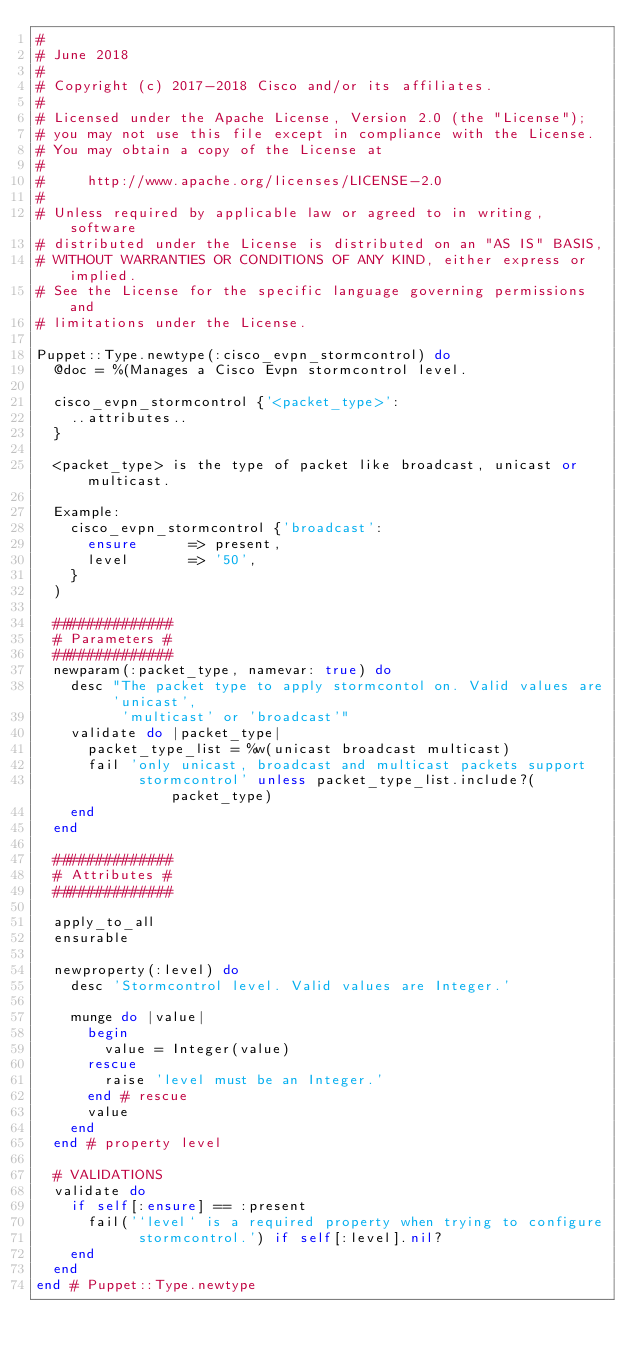Convert code to text. <code><loc_0><loc_0><loc_500><loc_500><_Ruby_>#
# June 2018
#
# Copyright (c) 2017-2018 Cisco and/or its affiliates.
#
# Licensed under the Apache License, Version 2.0 (the "License");
# you may not use this file except in compliance with the License.
# You may obtain a copy of the License at
#
#     http://www.apache.org/licenses/LICENSE-2.0
#
# Unless required by applicable law or agreed to in writing, software
# distributed under the License is distributed on an "AS IS" BASIS,
# WITHOUT WARRANTIES OR CONDITIONS OF ANY KIND, either express or implied.
# See the License for the specific language governing permissions and
# limitations under the License.

Puppet::Type.newtype(:cisco_evpn_stormcontrol) do
  @doc = %(Manages a Cisco Evpn stormcontrol level.

  cisco_evpn_stormcontrol {'<packet_type>':
    ..attributes..
  }

  <packet_type> is the type of packet like broadcast, unicast or multicast.

  Example:
    cisco_evpn_stormcontrol {'broadcast':
      ensure      => present,
      level       => '50',
    }
  )

  ##############
  # Parameters #
  ##############
  newparam(:packet_type, namevar: true) do
    desc "The packet type to apply stormcontol on. Valid values are 'unicast',
          'multicast' or 'broadcast'"
    validate do |packet_type|
      packet_type_list = %w(unicast broadcast multicast)
      fail 'only unicast, broadcast and multicast packets support
            stormcontrol' unless packet_type_list.include?(packet_type)
    end
  end

  ##############
  # Attributes #
  ##############

  apply_to_all
  ensurable

  newproperty(:level) do
    desc 'Stormcontrol level. Valid values are Integer.'

    munge do |value|
      begin
        value = Integer(value)
      rescue
        raise 'level must be an Integer.'
      end # rescue
      value
    end
  end # property level

  # VALIDATIONS
  validate do
    if self[:ensure] == :present
      fail('`level` is a required property when trying to configure
            stormcontrol.') if self[:level].nil?
    end
  end
end # Puppet::Type.newtype
</code> 